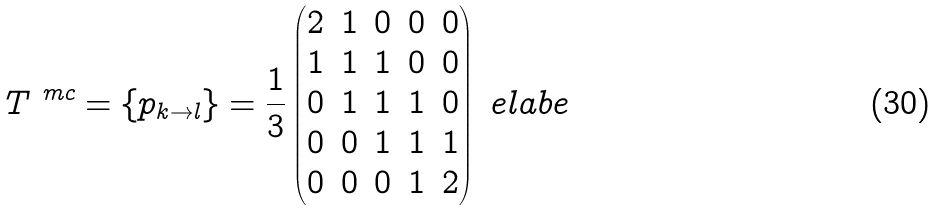Convert formula to latex. <formula><loc_0><loc_0><loc_500><loc_500>T ^ { \ m c } = \{ p _ { k \to l } \} = \frac { 1 } { 3 } \begin{pmatrix} 2 & 1 & 0 & 0 & 0 \\ 1 & 1 & 1 & 0 & 0 \\ 0 & 1 & 1 & 1 & 0 \\ 0 & 0 & 1 & 1 & 1 \\ 0 & 0 & 0 & 1 & 2 \\ \end{pmatrix} \ e l a b e</formula> 